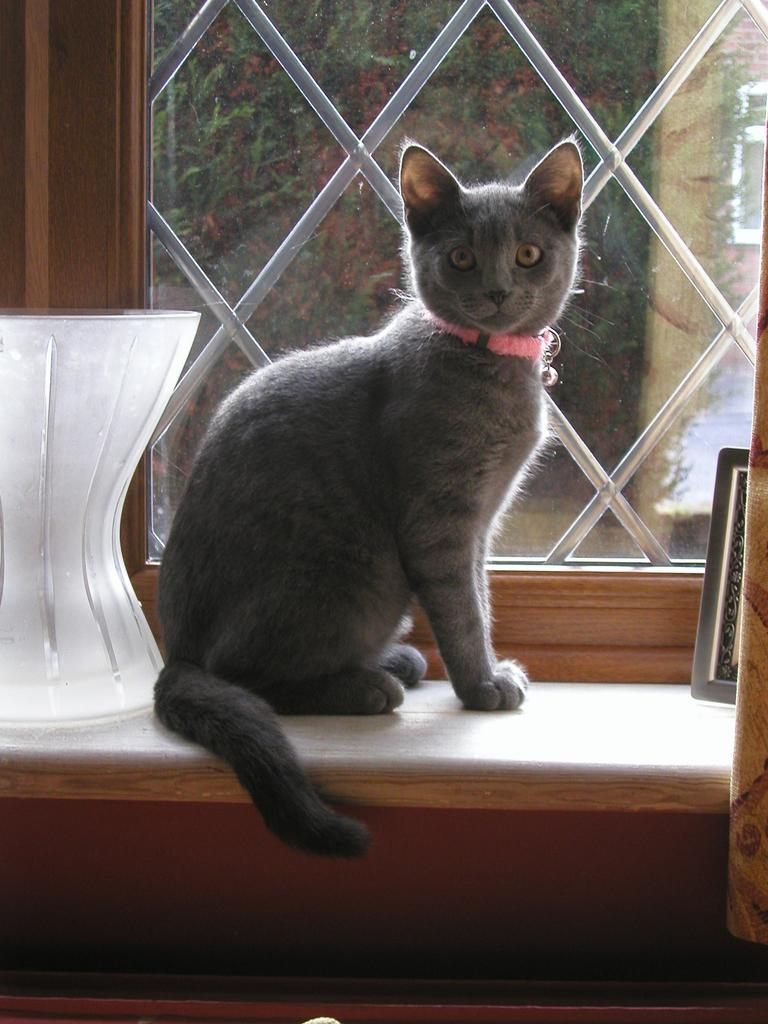What animal is on the table in the image? There is a cat on the table in the image. What other objects are on the table in the image? There is a vase and a photo frame on the table in the image. What can be seen through the window in the image? There are plants visible through the window in the image. What type of window treatment is present in the image? There is a curtain associated with the window in the image. What time does the clock in the image show? There is no clock present in the image, so it is not possible to determine the time. 